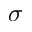Convert formula to latex. <formula><loc_0><loc_0><loc_500><loc_500>\sigma</formula> 